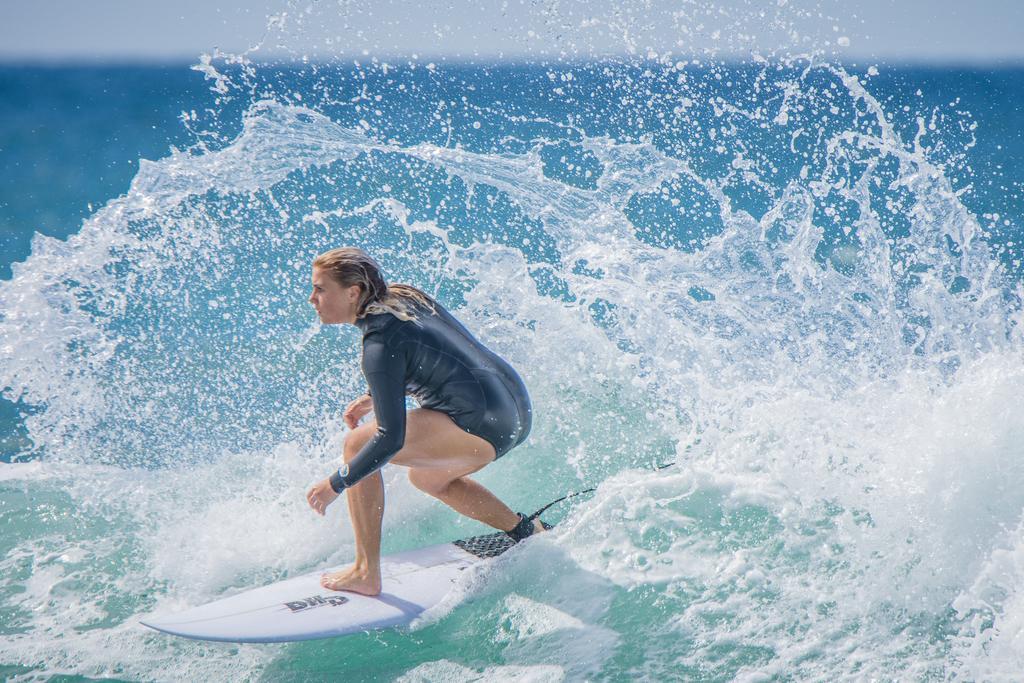How would you summarize this image in a sentence or two? In this image there is one woman surfing on the water as we can see in the bottom of this image. 